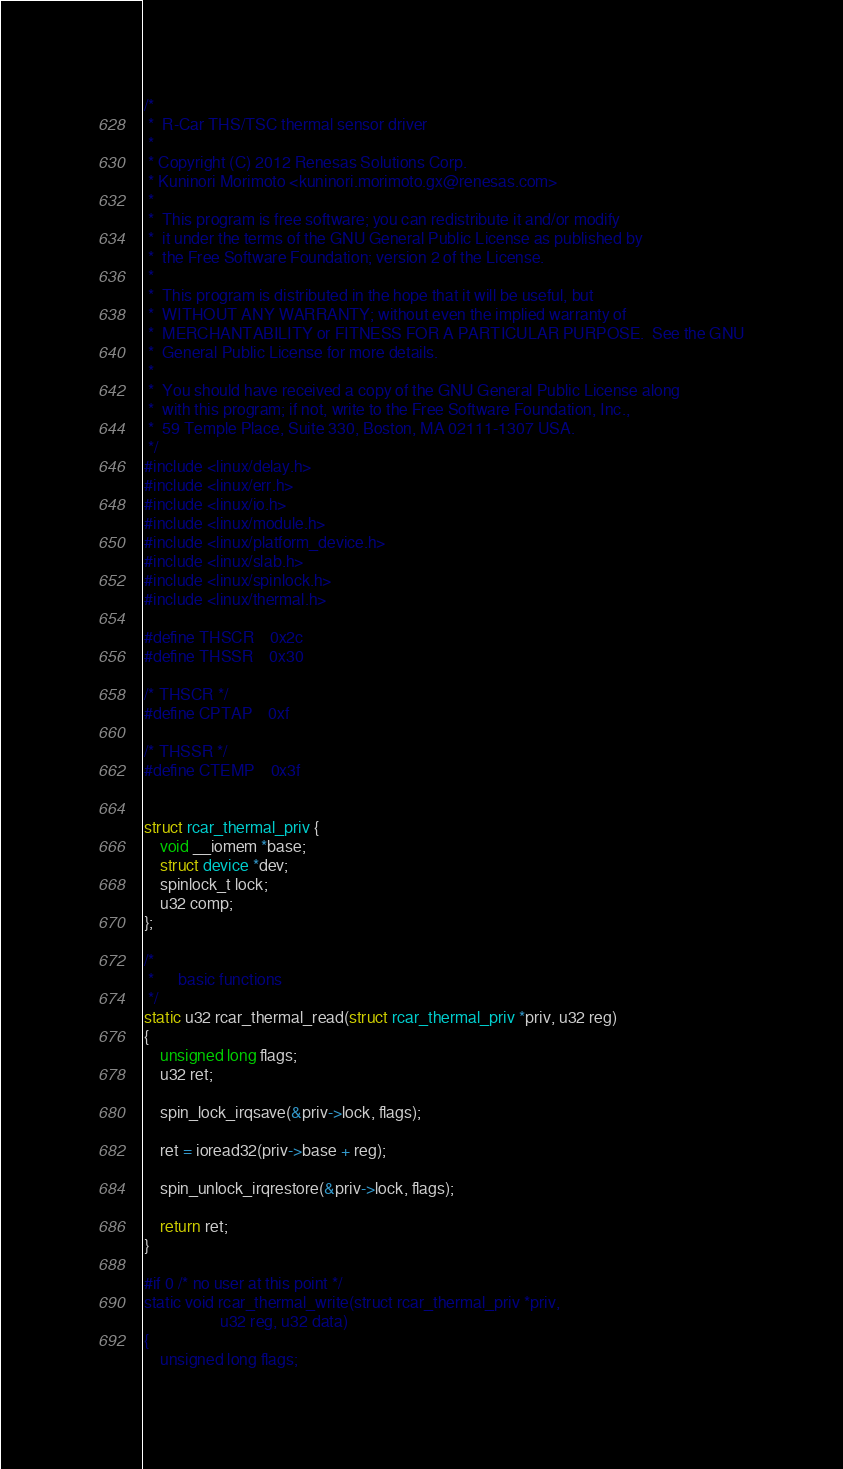<code> <loc_0><loc_0><loc_500><loc_500><_C_>/*
 *  R-Car THS/TSC thermal sensor driver
 *
 * Copyright (C) 2012 Renesas Solutions Corp.
 * Kuninori Morimoto <kuninori.morimoto.gx@renesas.com>
 *
 *  This program is free software; you can redistribute it and/or modify
 *  it under the terms of the GNU General Public License as published by
 *  the Free Software Foundation; version 2 of the License.
 *
 *  This program is distributed in the hope that it will be useful, but
 *  WITHOUT ANY WARRANTY; without even the implied warranty of
 *  MERCHANTABILITY or FITNESS FOR A PARTICULAR PURPOSE.  See the GNU
 *  General Public License for more details.
 *
 *  You should have received a copy of the GNU General Public License along
 *  with this program; if not, write to the Free Software Foundation, Inc.,
 *  59 Temple Place, Suite 330, Boston, MA 02111-1307 USA.
 */
#include <linux/delay.h>
#include <linux/err.h>
#include <linux/io.h>
#include <linux/module.h>
#include <linux/platform_device.h>
#include <linux/slab.h>
#include <linux/spinlock.h>
#include <linux/thermal.h>

#define THSCR	0x2c
#define THSSR	0x30

/* THSCR */
#define CPTAP	0xf

/* THSSR */
#define CTEMP	0x3f


struct rcar_thermal_priv {
	void __iomem *base;
	struct device *dev;
	spinlock_t lock;
	u32 comp;
};

/*
 *		basic functions
 */
static u32 rcar_thermal_read(struct rcar_thermal_priv *priv, u32 reg)
{
	unsigned long flags;
	u32 ret;

	spin_lock_irqsave(&priv->lock, flags);

	ret = ioread32(priv->base + reg);

	spin_unlock_irqrestore(&priv->lock, flags);

	return ret;
}

#if 0 /* no user at this point */
static void rcar_thermal_write(struct rcar_thermal_priv *priv,
			       u32 reg, u32 data)
{
	unsigned long flags;
</code> 